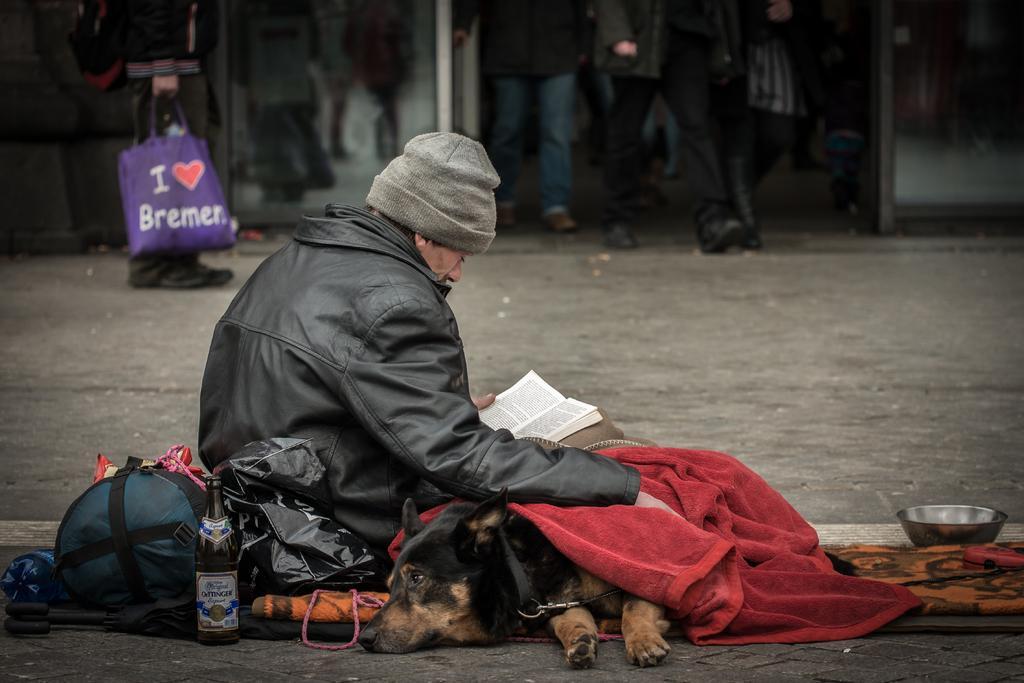Please provide a concise description of this image. In this image I can see a man is sitting along with the dog on the ground. I can also see there is a bag, glass bottle and other objects on the ground. The man is wearing a cap and reading book by holding in his hand. 